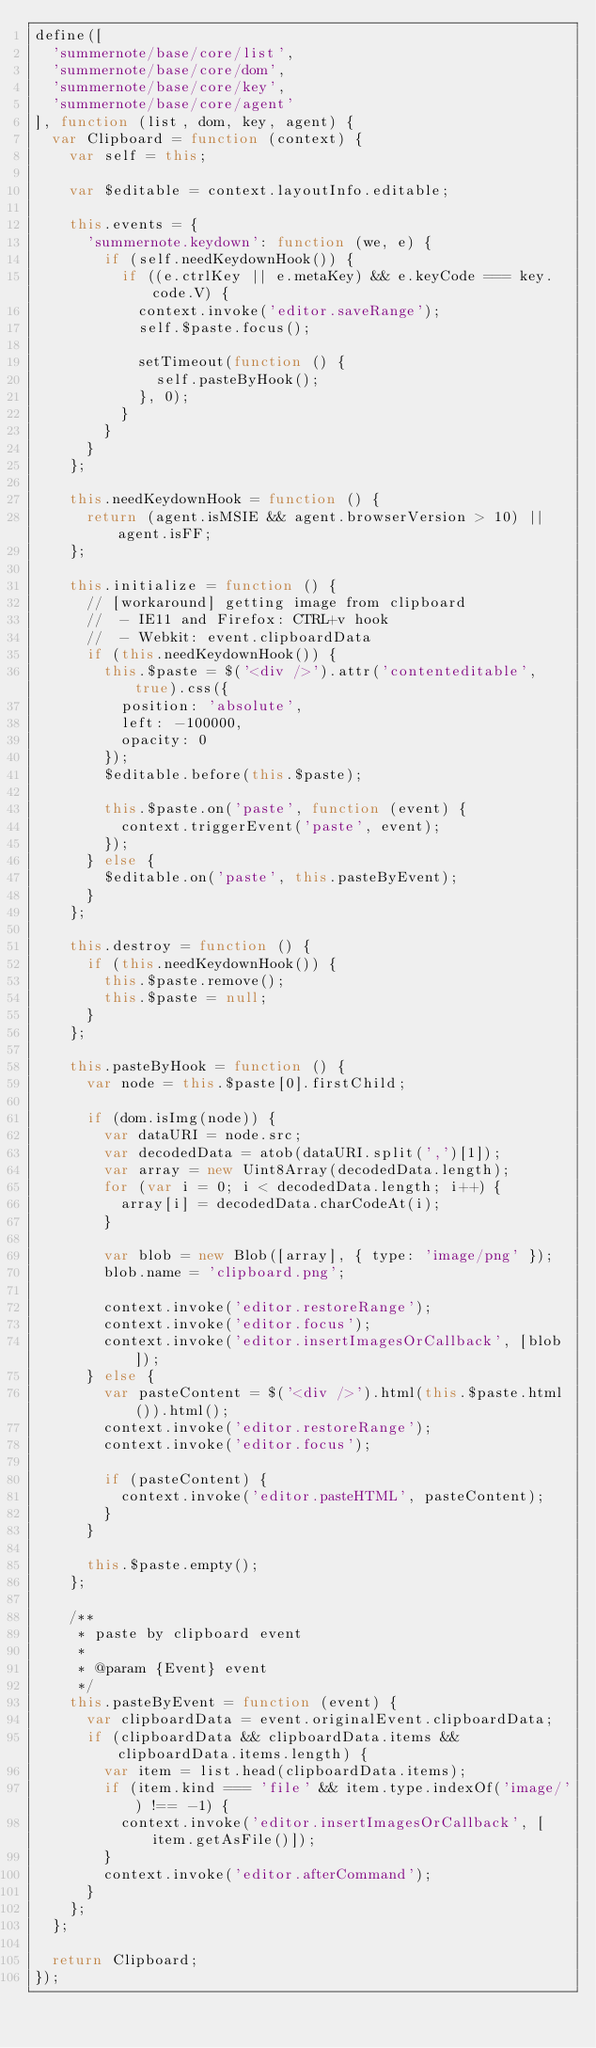<code> <loc_0><loc_0><loc_500><loc_500><_JavaScript_>define([
  'summernote/base/core/list',
  'summernote/base/core/dom',
  'summernote/base/core/key',
  'summernote/base/core/agent'
], function (list, dom, key, agent) {
  var Clipboard = function (context) {
    var self = this;

    var $editable = context.layoutInfo.editable;

    this.events = {
      'summernote.keydown': function (we, e) {
        if (self.needKeydownHook()) {
          if ((e.ctrlKey || e.metaKey) && e.keyCode === key.code.V) {
            context.invoke('editor.saveRange');
            self.$paste.focus();

            setTimeout(function () {
              self.pasteByHook();
            }, 0);
          }
        }
      }
    };

    this.needKeydownHook = function () {
      return (agent.isMSIE && agent.browserVersion > 10) || agent.isFF;
    };

    this.initialize = function () {
      // [workaround] getting image from clipboard
      //  - IE11 and Firefox: CTRL+v hook
      //  - Webkit: event.clipboardData
      if (this.needKeydownHook()) {
        this.$paste = $('<div />').attr('contenteditable', true).css({
          position: 'absolute',
          left: -100000,
          opacity: 0
        });
        $editable.before(this.$paste);

        this.$paste.on('paste', function (event) {
          context.triggerEvent('paste', event);
        });
      } else {
        $editable.on('paste', this.pasteByEvent);
      }
    };

    this.destroy = function () {
      if (this.needKeydownHook()) {
        this.$paste.remove();
        this.$paste = null;
      }
    };

    this.pasteByHook = function () {
      var node = this.$paste[0].firstChild;

      if (dom.isImg(node)) {
        var dataURI = node.src;
        var decodedData = atob(dataURI.split(',')[1]);
        var array = new Uint8Array(decodedData.length);
        for (var i = 0; i < decodedData.length; i++) {
          array[i] = decodedData.charCodeAt(i);
        }

        var blob = new Blob([array], { type: 'image/png' });
        blob.name = 'clipboard.png';

        context.invoke('editor.restoreRange');
        context.invoke('editor.focus');
        context.invoke('editor.insertImagesOrCallback', [blob]);
      } else {
        var pasteContent = $('<div />').html(this.$paste.html()).html();
        context.invoke('editor.restoreRange');
        context.invoke('editor.focus');

        if (pasteContent) {
          context.invoke('editor.pasteHTML', pasteContent);
        }
      }

      this.$paste.empty();
    };

    /**
     * paste by clipboard event
     *
     * @param {Event} event
     */
    this.pasteByEvent = function (event) {
      var clipboardData = event.originalEvent.clipboardData;
      if (clipboardData && clipboardData.items && clipboardData.items.length) {
        var item = list.head(clipboardData.items);
        if (item.kind === 'file' && item.type.indexOf('image/') !== -1) {
          context.invoke('editor.insertImagesOrCallback', [item.getAsFile()]);
        }
        context.invoke('editor.afterCommand');
      }
    };
  };

  return Clipboard;
});
</code> 